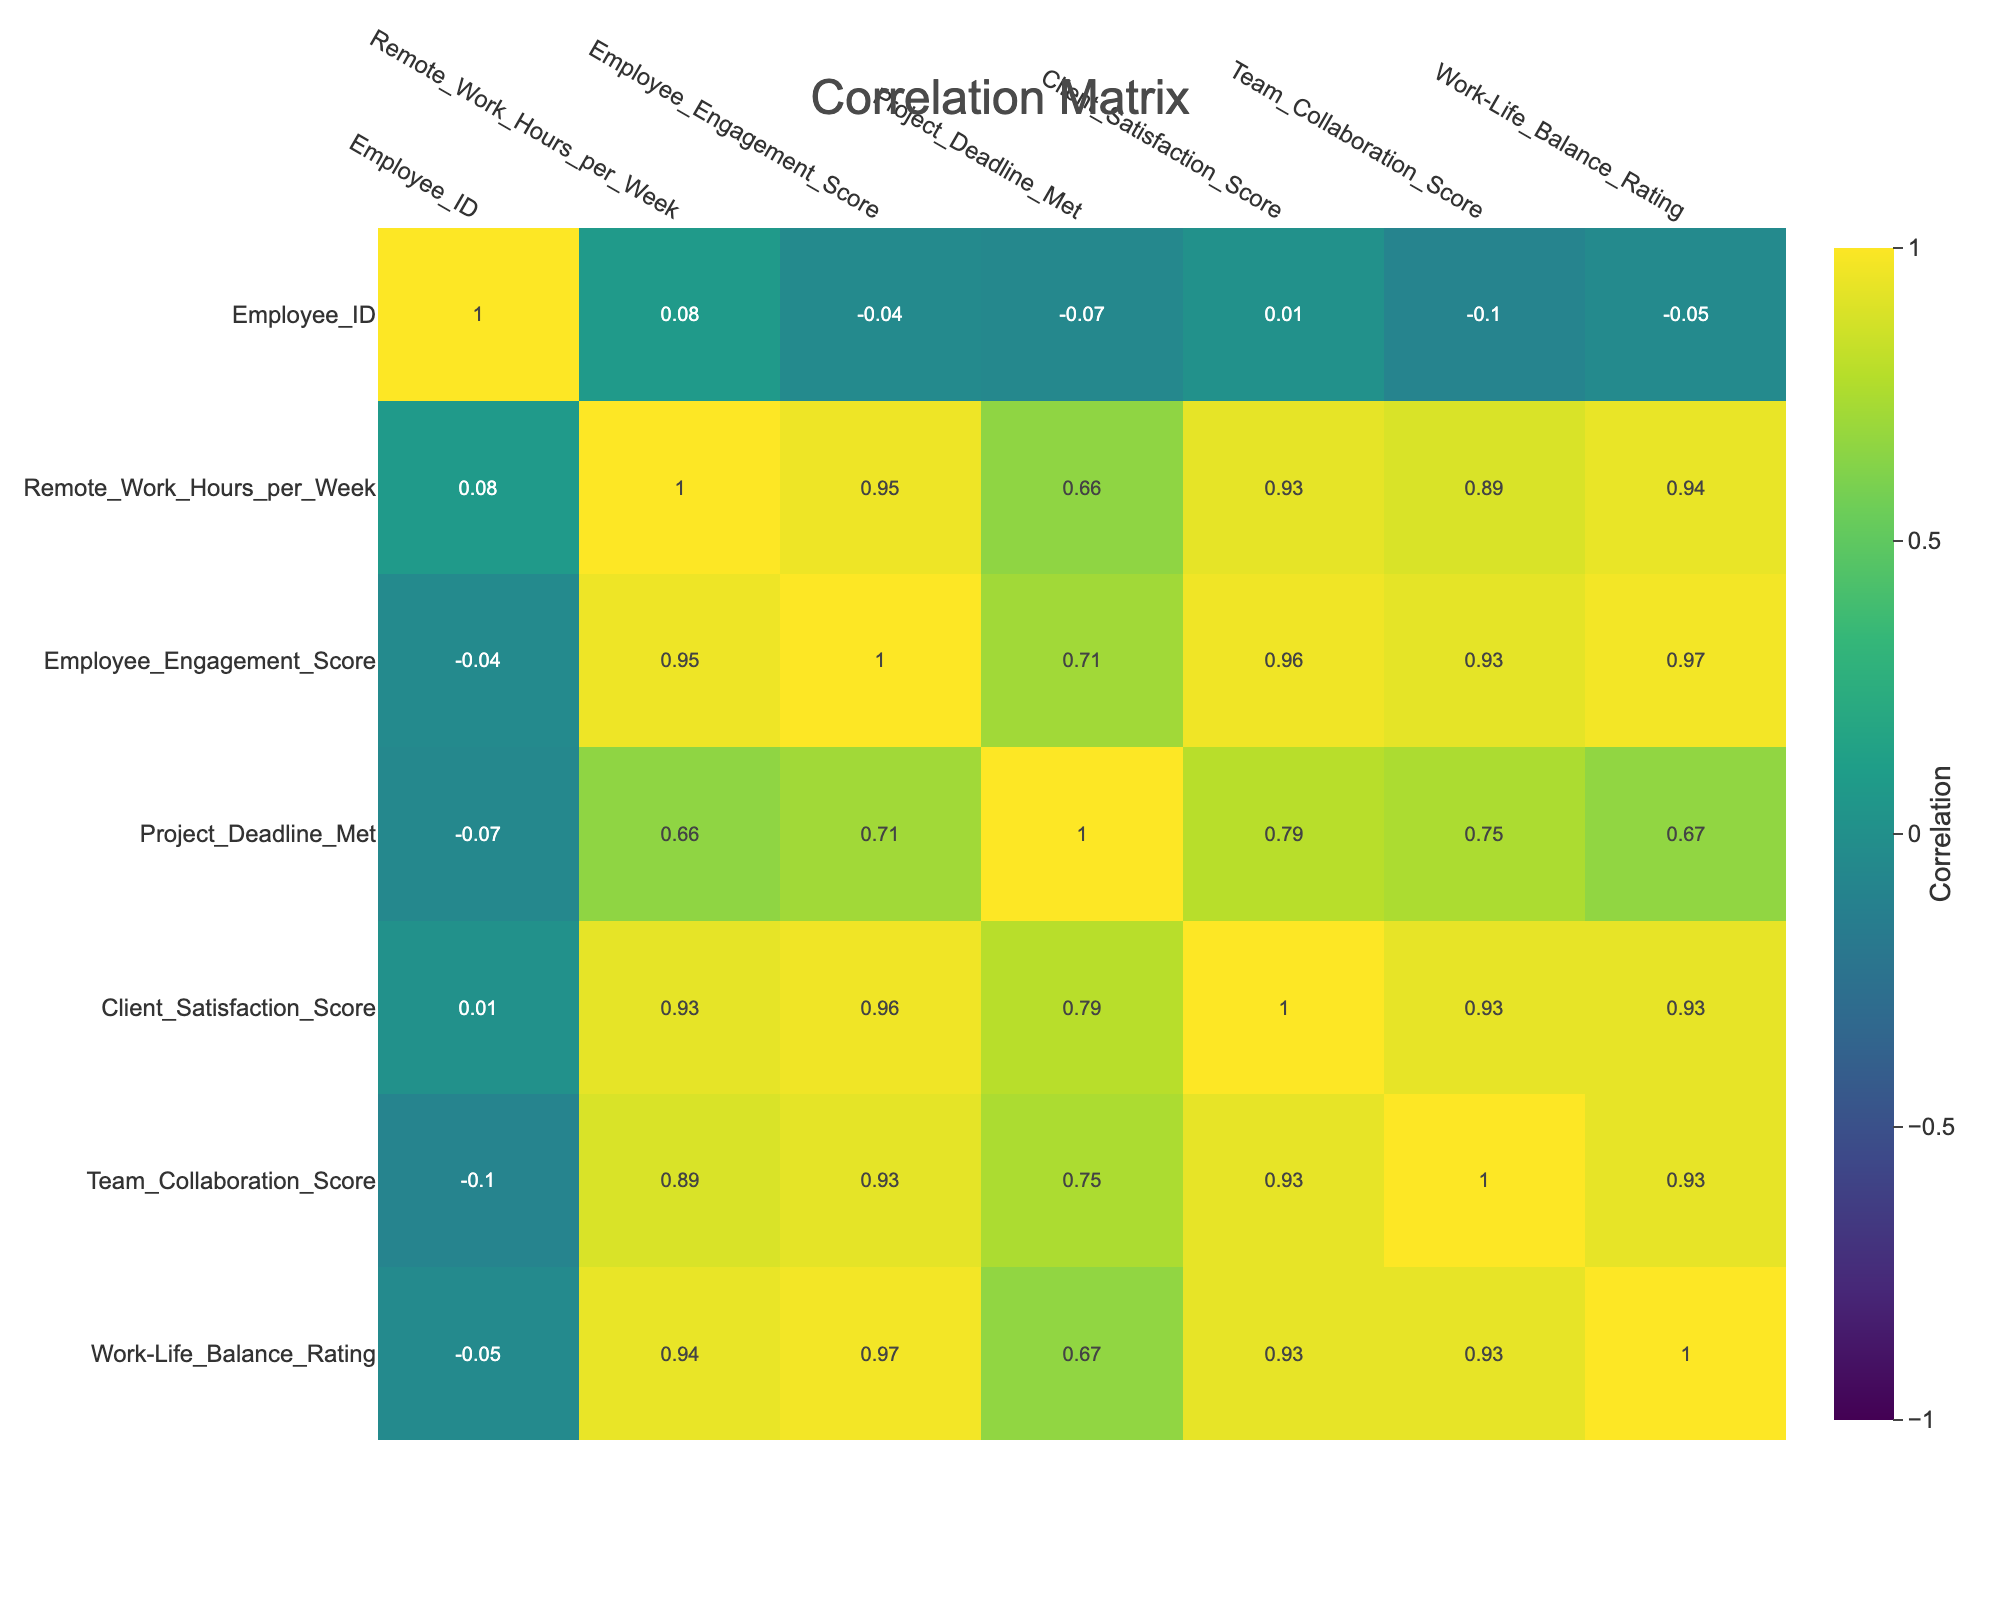What is the correlation between remote work hours and employee engagement scores? To find the correlation, we need to look at the correlation matrix provided in the table. The correlation value between "Remote_Work_Hours_per_Week" and "Employee_Engagement_Score" is 0.78, indicating a strong positive relationship.
Answer: 0.78 Did any employee with fewer than 30 remote work hours per week have a positive employee engagement score? Looking at the data for employees with fewer than 30 remote work hours, only one employee (Employee ID 11) with 15 remote work hours had an engagement score of 45, which is not positive. Hence, the answer is no.
Answer: No What are the average client satisfaction scores for employees who met the project deadline? First, we need to identify the employees who met the project deadline (indicated by 1). Then, we can sum their client satisfaction scores (90 + 85 + 95 + 87 + 92 + 96 + 91 + 84 + 93 = 819) and divide by the number of employees who met the deadline (8). Thus, the average is 819 / 8 = 102.375.
Answer: 102.375 Is there any employee who worked more than 50 hours and had an engagement score lower than 70? We check the employees who worked more than 50 remote work hours (Employees 3, 8, and 10). All these employees (employee 3 with 90 engagement, employee 8 with 88 engagement, employee 10 with 92 engagement) have engagement scores above 70, so no employee meets the condition.
Answer: No What is the difference in the average work-life balance rating between employees who met the project deadline and those who did not? First, we find the average work-life balance rating for employees who met the deadline (ratings of employees 1, 2, 3, 5, 7, 8, 10, 13, 14, and 15 = (4 + 3 + 5 + 4 + 4 + 5 + 5 + 3 + 3 + 5) / 10 = 4.0). For those who did not meet the deadline (ratings of employees 4, 6, 9, 11, and 12 = (3 + 2 + 2 + 1 + 4) / 5 = 2.4). The difference between these averages is 4.0 - 2.4 = 1.6.
Answer: 1.6 What is the correlation between team collaboration score and client satisfaction score? We look at the correlation matrix and find that the correlation between "Team_Collaboration_Score" and "Client_Satisfaction_Score" is 0.88. This suggests a very strong positive correlation, indicating that as team collaboration improves, client satisfaction also tends to improve significantly.
Answer: 0.88 